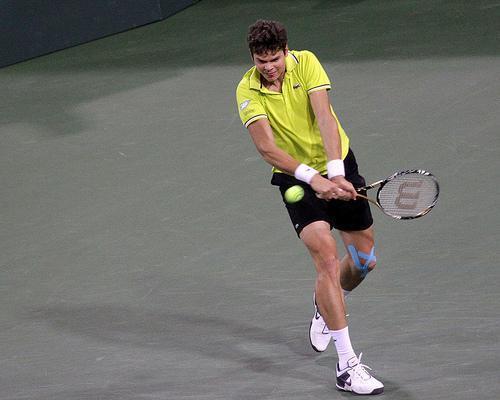How many people are in the picture?
Give a very brief answer. 1. 